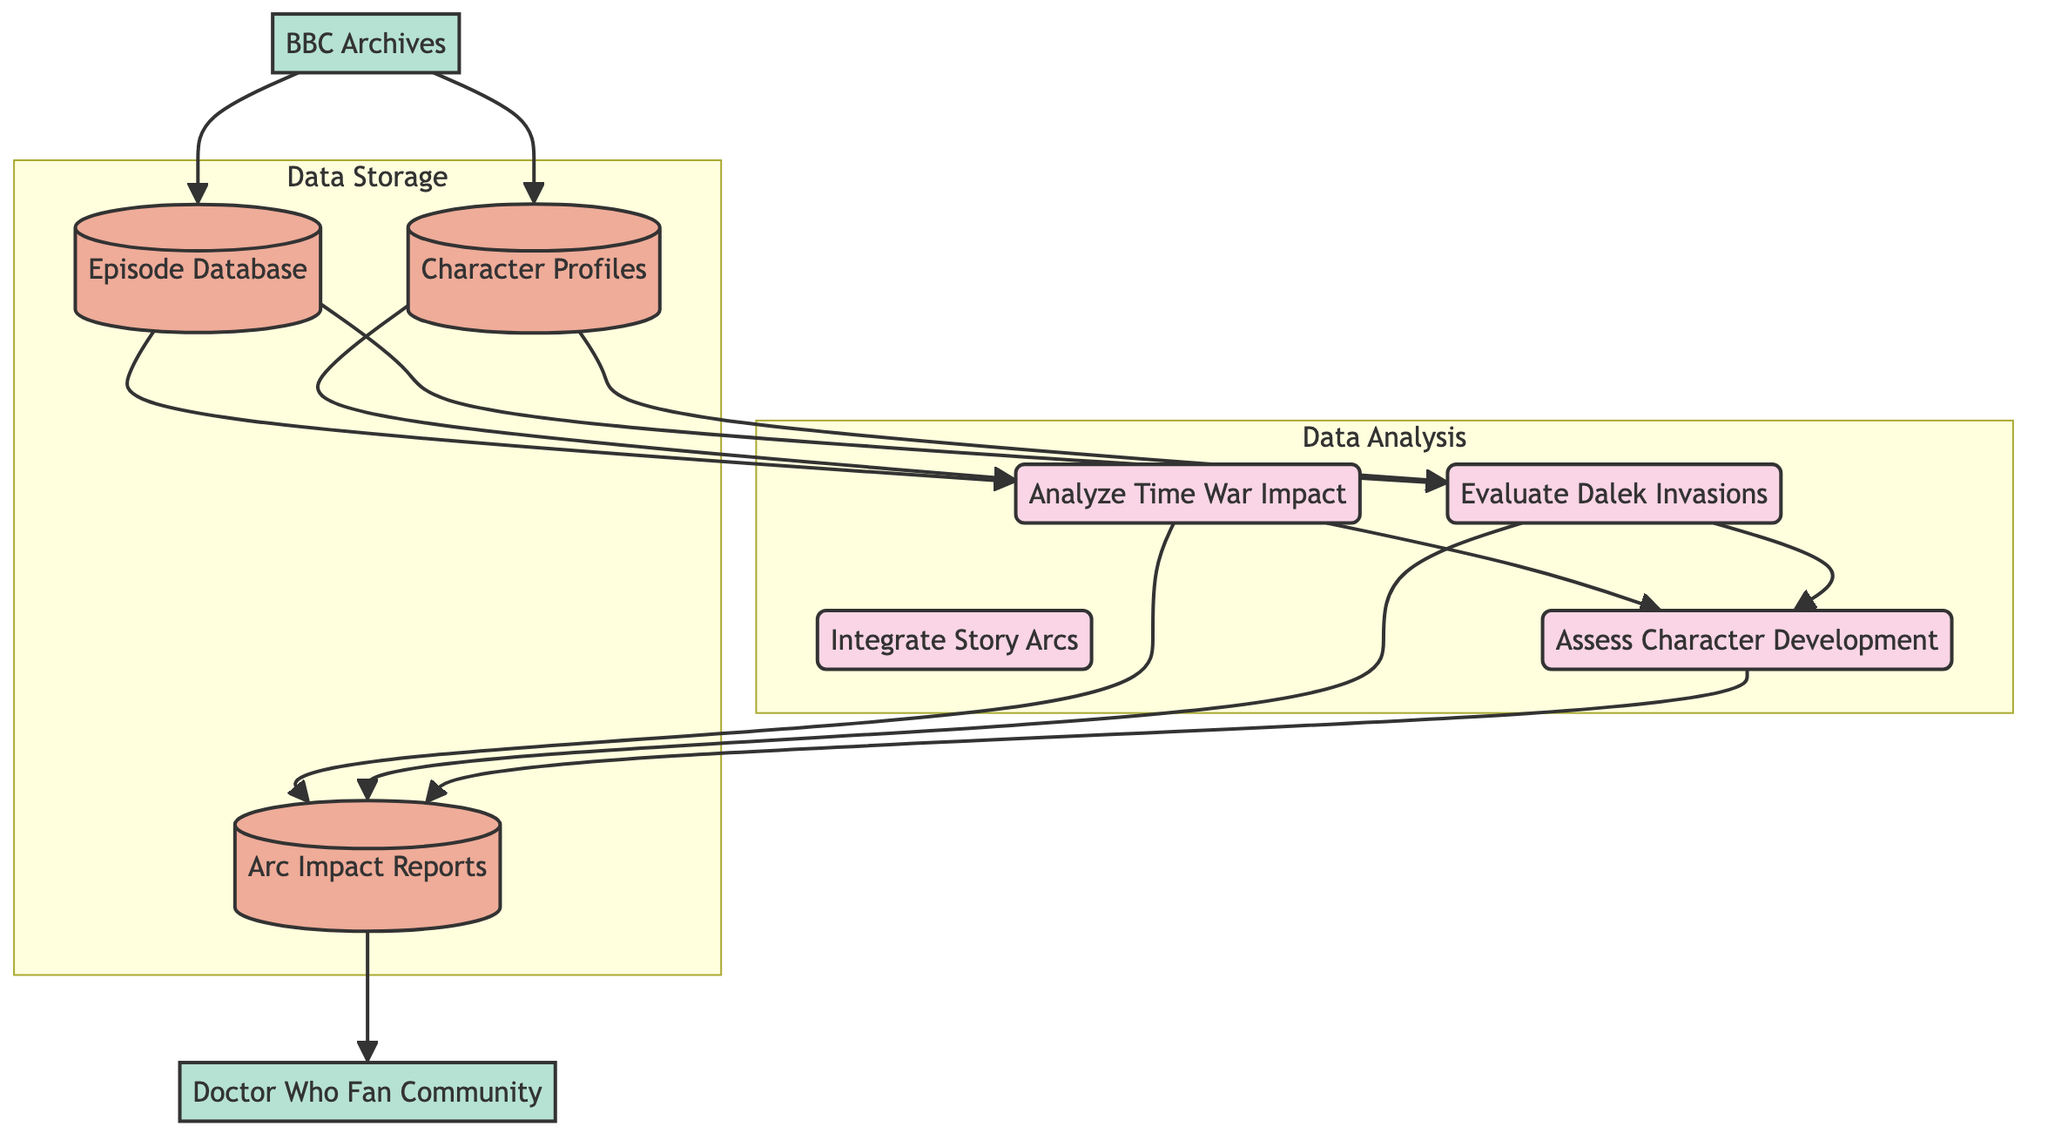What are the two main processes analyzing impacts in the diagram? The diagram has two main processes related to analysis: "Analyze Time War Impact" and "Evaluate Dalek Invasions." These processes are focused on studying the influences of specific story arcs.
Answer: Analyze Time War Impact, Evaluate Dalek Invasions Which data store contains information on all Doctor Who episodes? The data store labeled "Episode Database" is explicitly described as containing information on all Doctor Who episodes.
Answer: Episode Database How many data flows are associated with the "Assess Character Development" process? The process "Assess Character Development" receives data from two other processes: "Analyze Time War Impact" and "Evaluate Dalek Invasions," leading to a total of two data flows directed into it.
Answer: 2 What external entity provides archival data for episodes? The external entity "BBC Archives" is the source that provides archival data for episodes and characters, as indicated in the diagram.
Answer: BBC Archives Which data store receives the results from both analysis processes? Both "Analyze Time War Impact" and "Evaluate Dalek Invasions" processes send their results to the data store "Arc Impact Reports," indicating it collects data from both analyses.
Answer: Arc Impact Reports What type of data does the "Episode Database" supply to the "Analyze Time War Impact" process? The "Episode Database" supplies episode data specifically for analyzing the impact of the Time War, emphasizing its role in feeding relevant information to this process.
Answer: Episode data What is the purpose of the "Assess Character Development" process? The "Assess Character Development" process evaluates how characters have evolved due to the story arcs, synthesizing findings from both the Time War and Dalek invasion analyses.
Answer: Assess character evolution How many external entities are represented in this diagram? There are two external entities represented in the diagram: "Doctor Who Fan Community" and "BBC Archives." This indicates interactions with both fan groups and archival sources.
Answer: 2 What is the output of the "Assess Character Development" process? The "Assess Character Development" process outputs results that are stored in "Arc Impact Reports," summarizing the evaluation of character evolution influenced by the analyzed story arcs.
Answer: Arc Impact Reports 